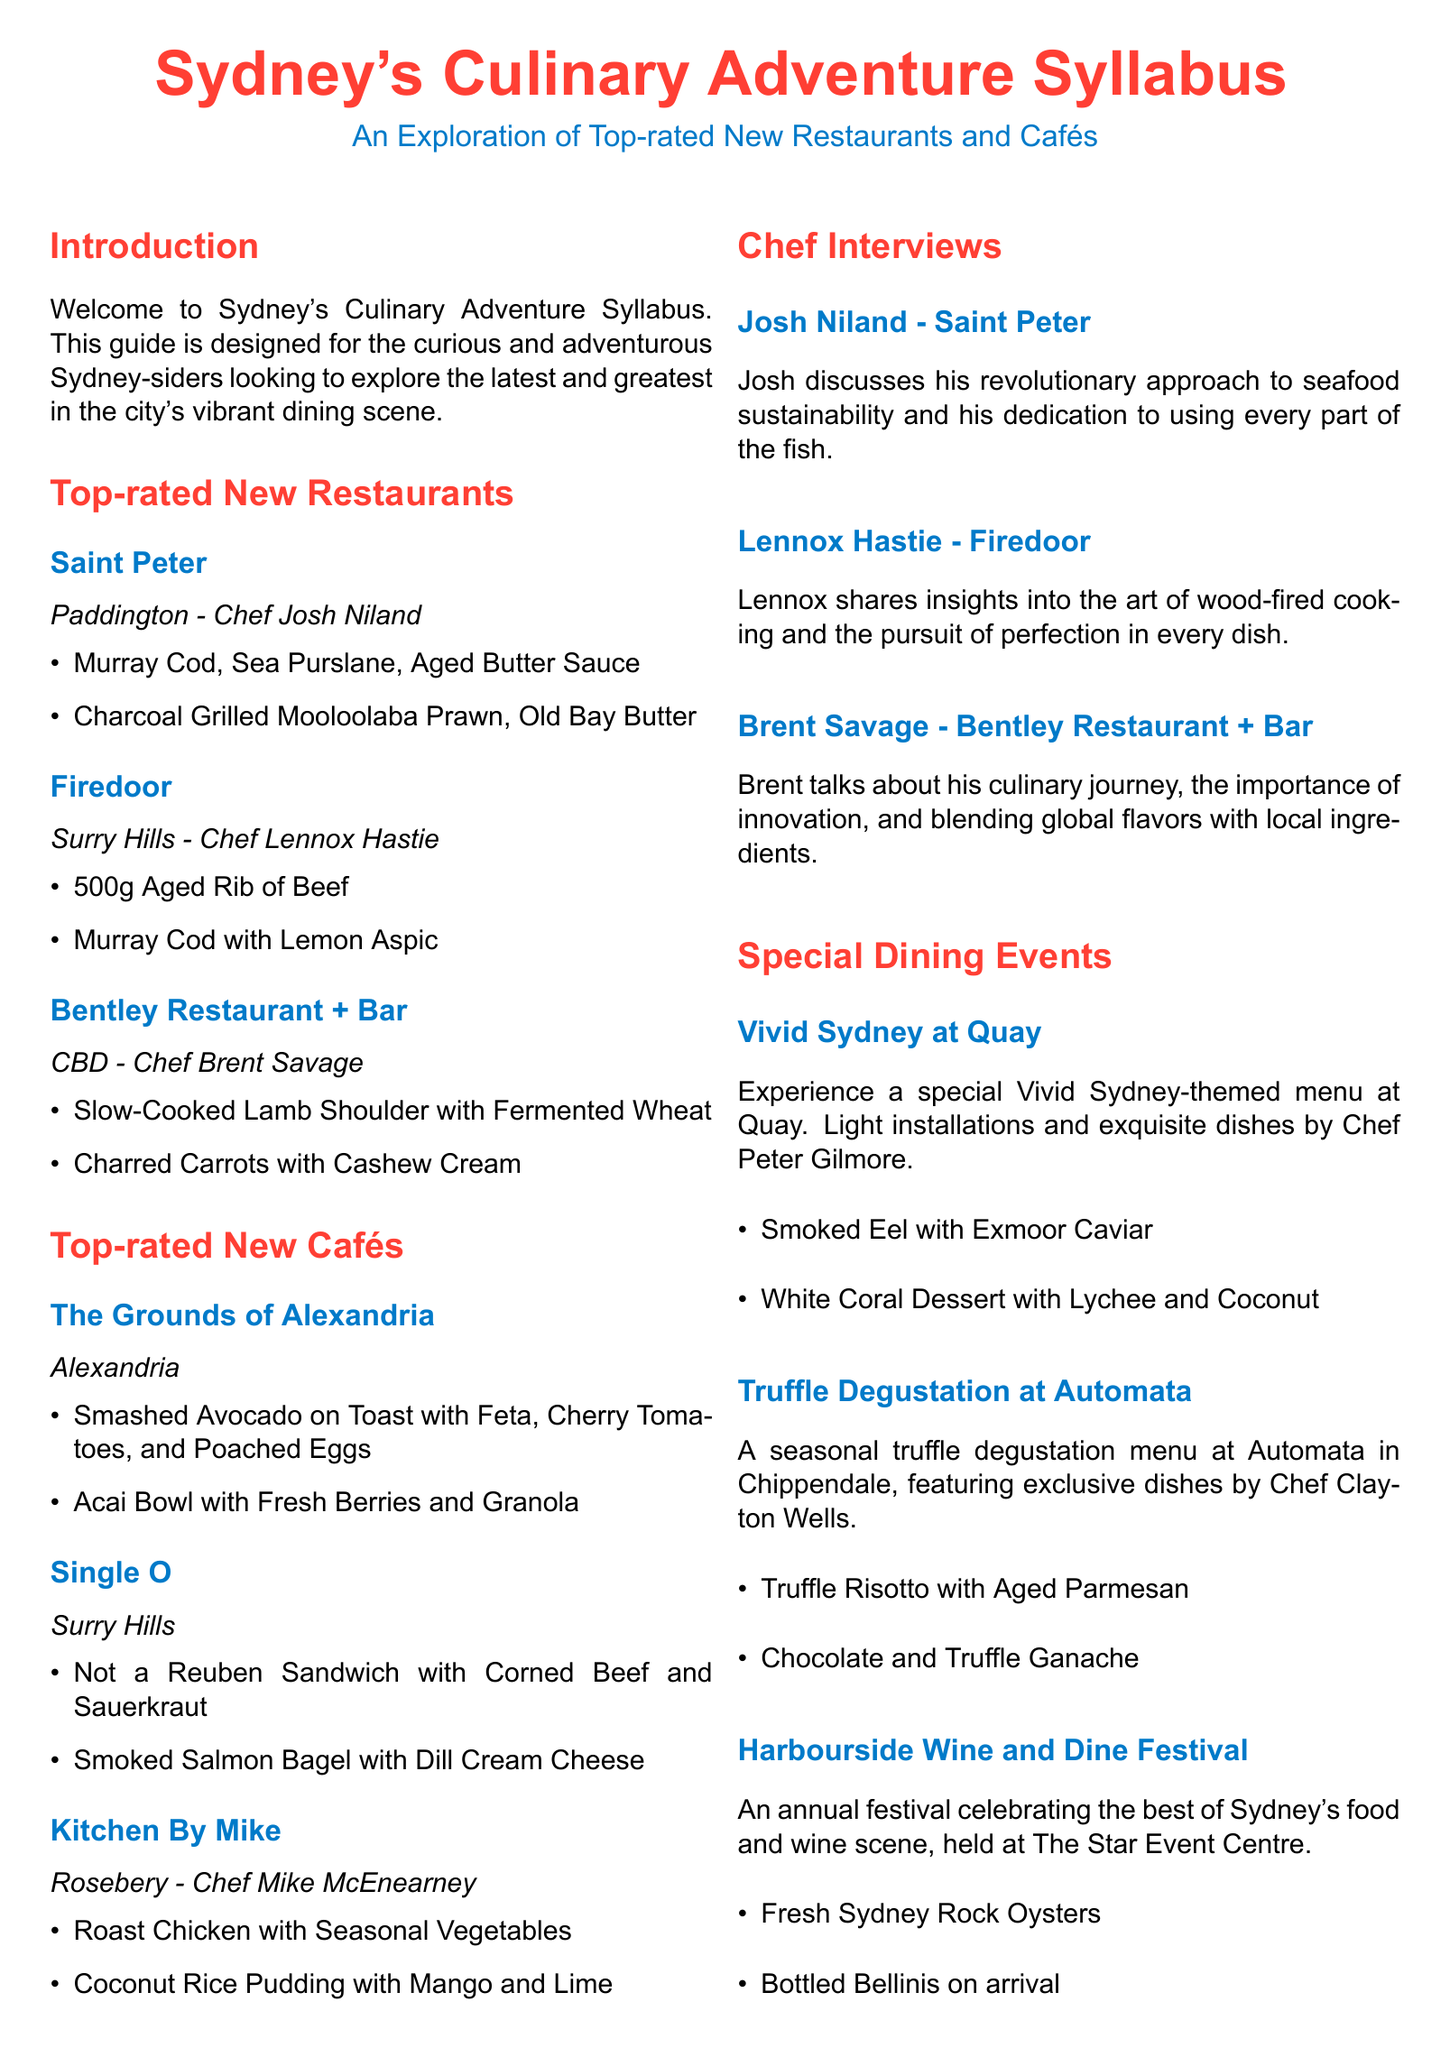What is the name of the chef at Saint Peter? The document lists Chef Josh Niland as the chef at Saint Peter.
Answer: Josh Niland What is a highlighted dish at Firedoor? The syllabus mentions "500g Aged Rib of Beef" as a dish highlight at Firedoor.
Answer: 500g Aged Rib of Beef Which café is located in Alexandria? The Grounds of Alexandria is specifically mentioned as being located in Alexandria.
Answer: The Grounds of Alexandria What interview topic is discussed by Lennox Hastie? Lennox shares insights into the art of wood-fired cooking.
Answer: wood-fired cooking What type of event is 'Harbourside Wine and Dine Festival'? It is an annual festival celebrating Sydney's food and wine scene.
Answer: annual festival What is a dish served at the Vivid Sydney event at Quay? The document highlights "Smoked Eel with Exmoor Caviar" as one of the dishes served.
Answer: Smoked Eel with Exmoor Caviar How many top-rated new restaurants are mentioned? The syllabus lists three top-rated new restaurants.
Answer: three What cuisine focus is mentioned in the Bentley Restaurant + Bar section? The document describes Brent Savage blending global flavors with local ingredients.
Answer: global flavors with local ingredients 